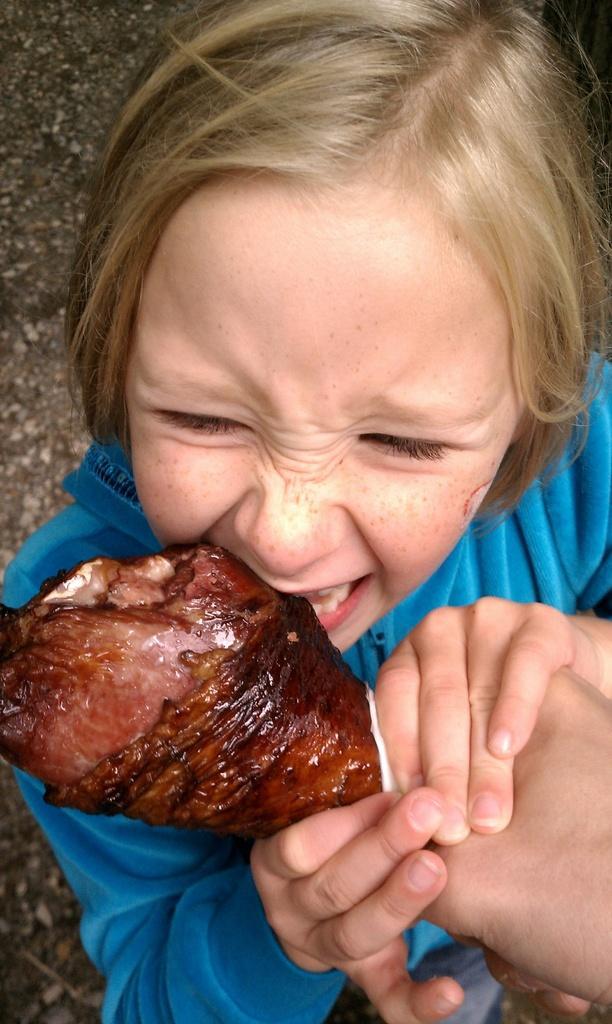In one or two sentences, can you explain what this image depicts? In this picture I can see a girl eating food item which is holding by another person hand. 